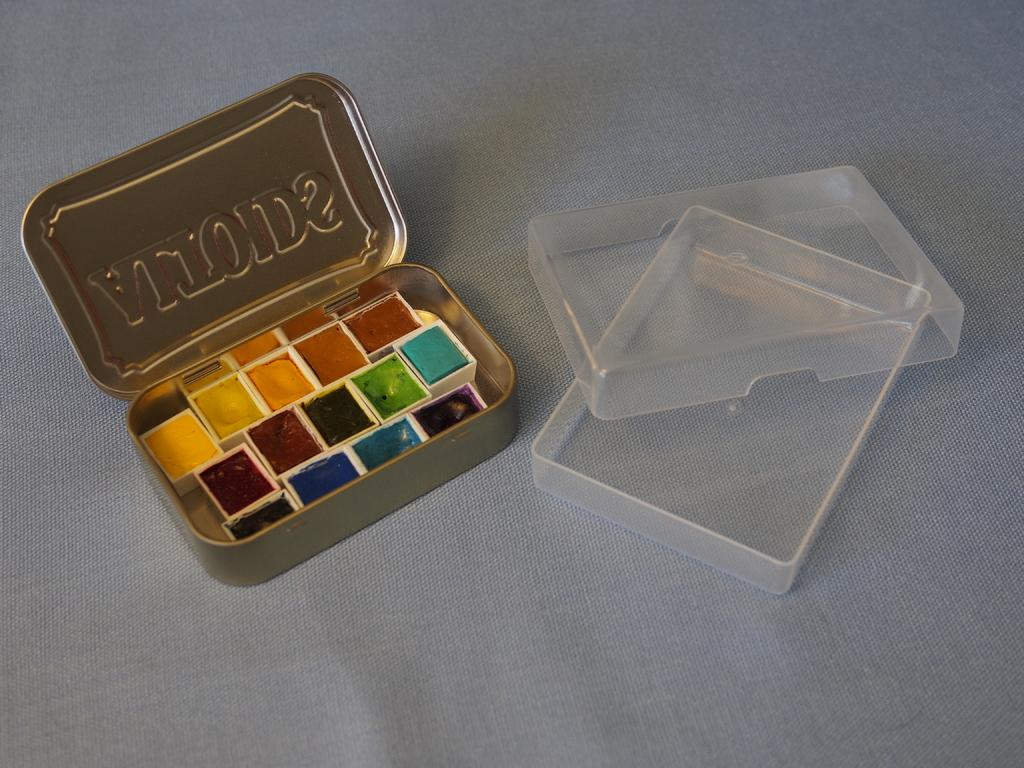What object is present in the image that contains something? There is a box in the image that contains colors. What type of containers are located on the right side of the image? There are plastic boxes on the right side of the image. What can be seen at the bottom of the image? There is a cloth at the bottom of the image. What type of toothpaste is visible in the image? There is no toothpaste present in the image. Can you describe the mist in the image? There is no mist present in the image. 